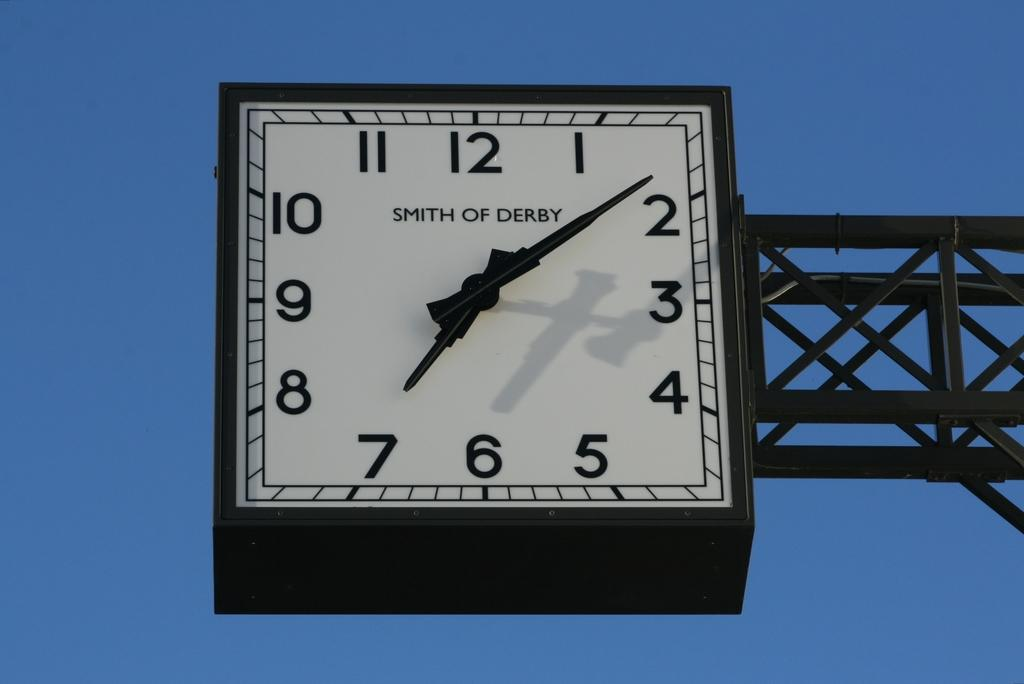<image>
Render a clear and concise summary of the photo. Smith of Derby clock tower in the city showing 7:08 p.m. 